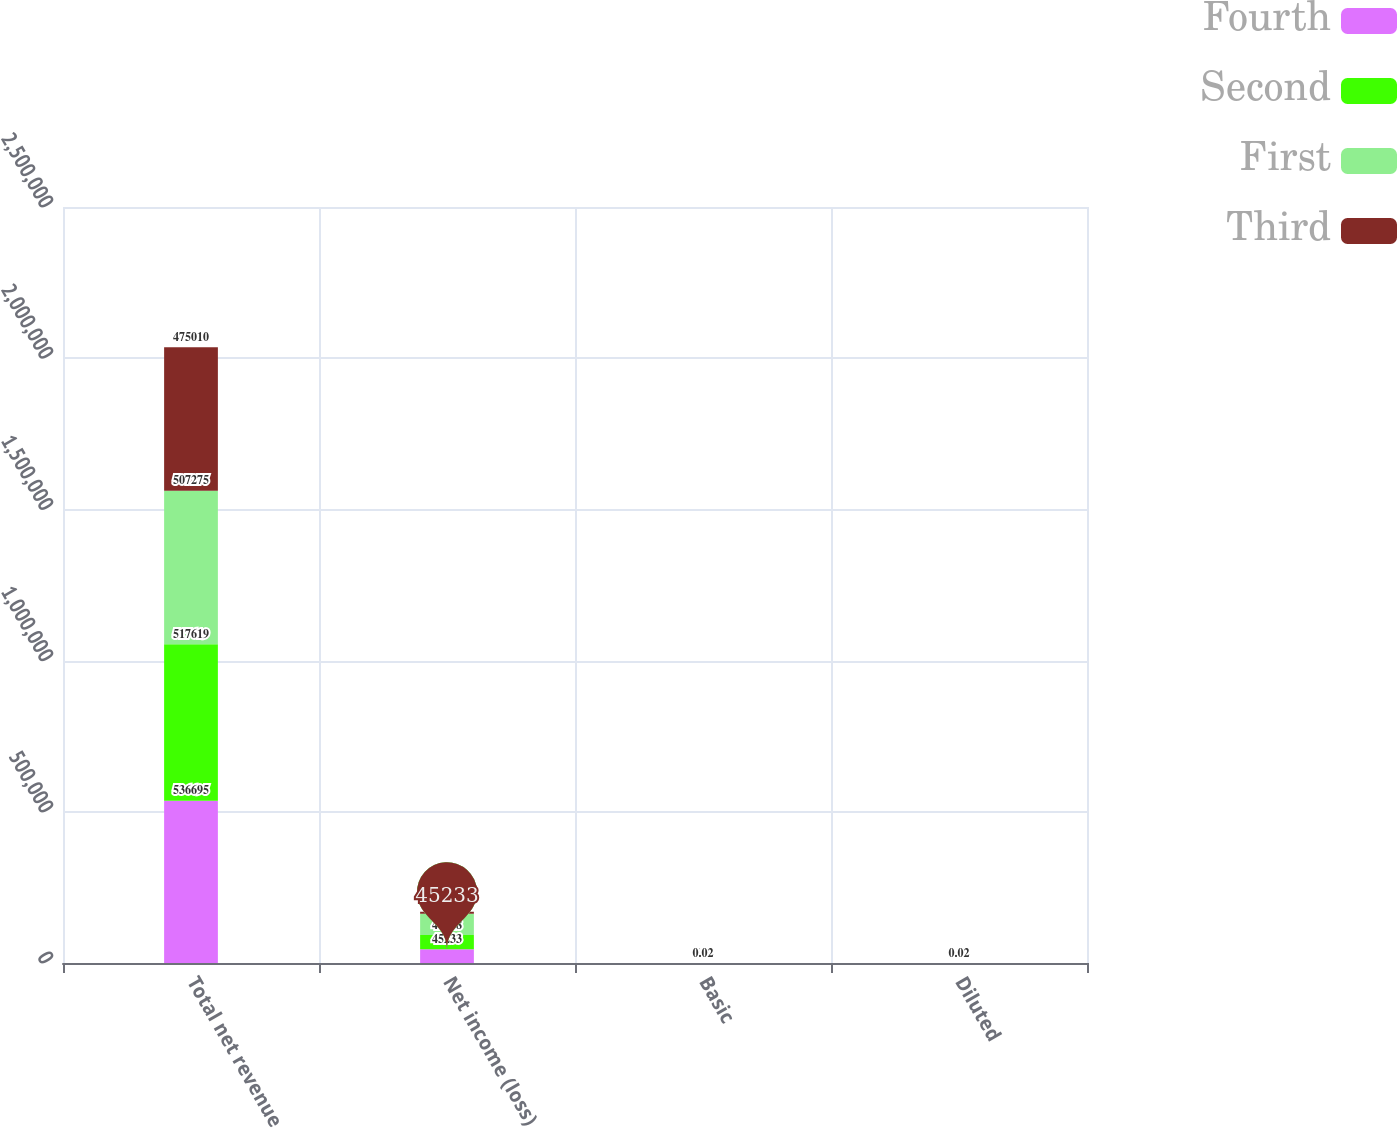Convert chart to OTSL. <chart><loc_0><loc_0><loc_500><loc_500><stacked_bar_chart><ecel><fcel>Total net revenue<fcel>Net income (loss)<fcel>Basic<fcel>Diluted<nl><fcel>Fourth<fcel>536695<fcel>45233<fcel>0.2<fcel>0.16<nl><fcel>Second<fcel>517619<fcel>47118<fcel>0.18<fcel>0.16<nl><fcel>First<fcel>507275<fcel>70696<fcel>0.25<fcel>0.24<nl><fcel>Third<fcel>475010<fcel>6346<fcel>0.02<fcel>0.02<nl></chart> 